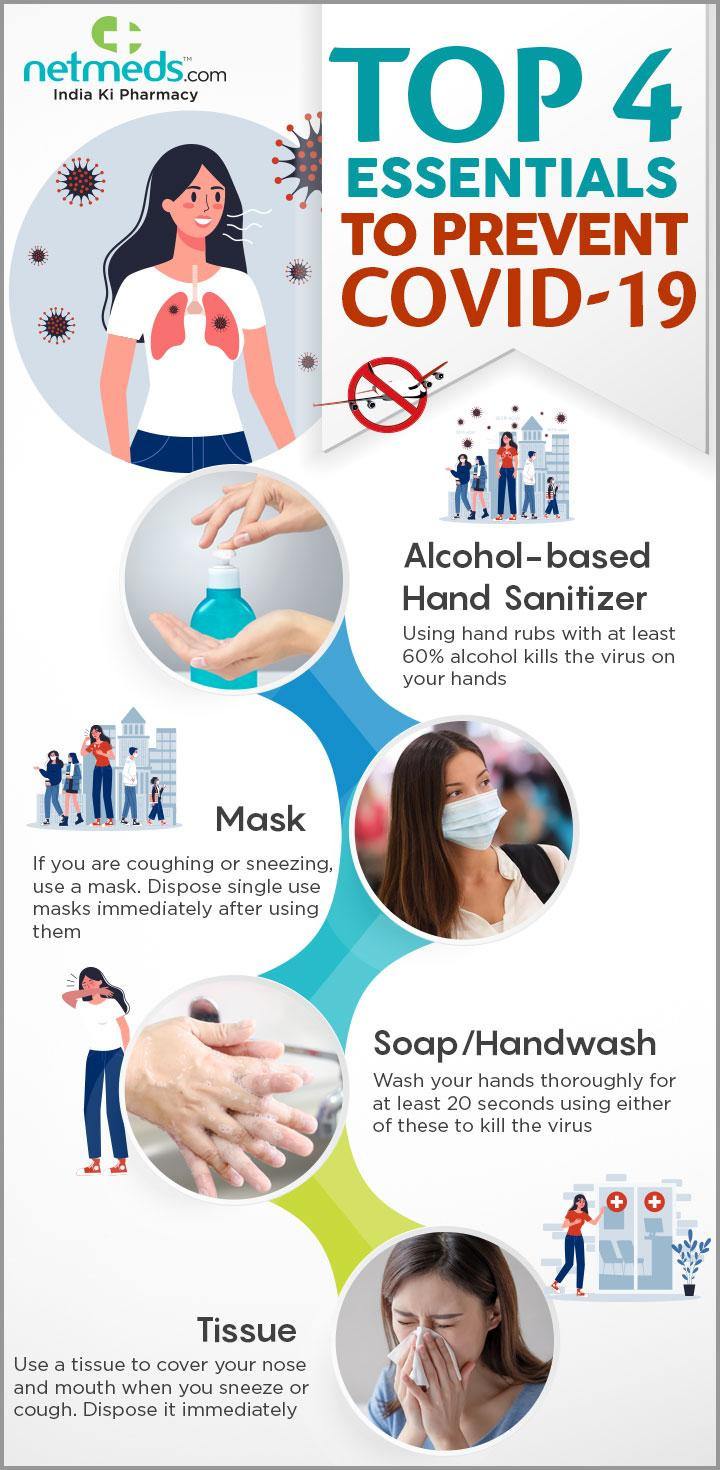Draw attention to some important aspects in this diagram. It is important to dispose of tissue right after coughing or sneezing to prevent the spread of germs. 